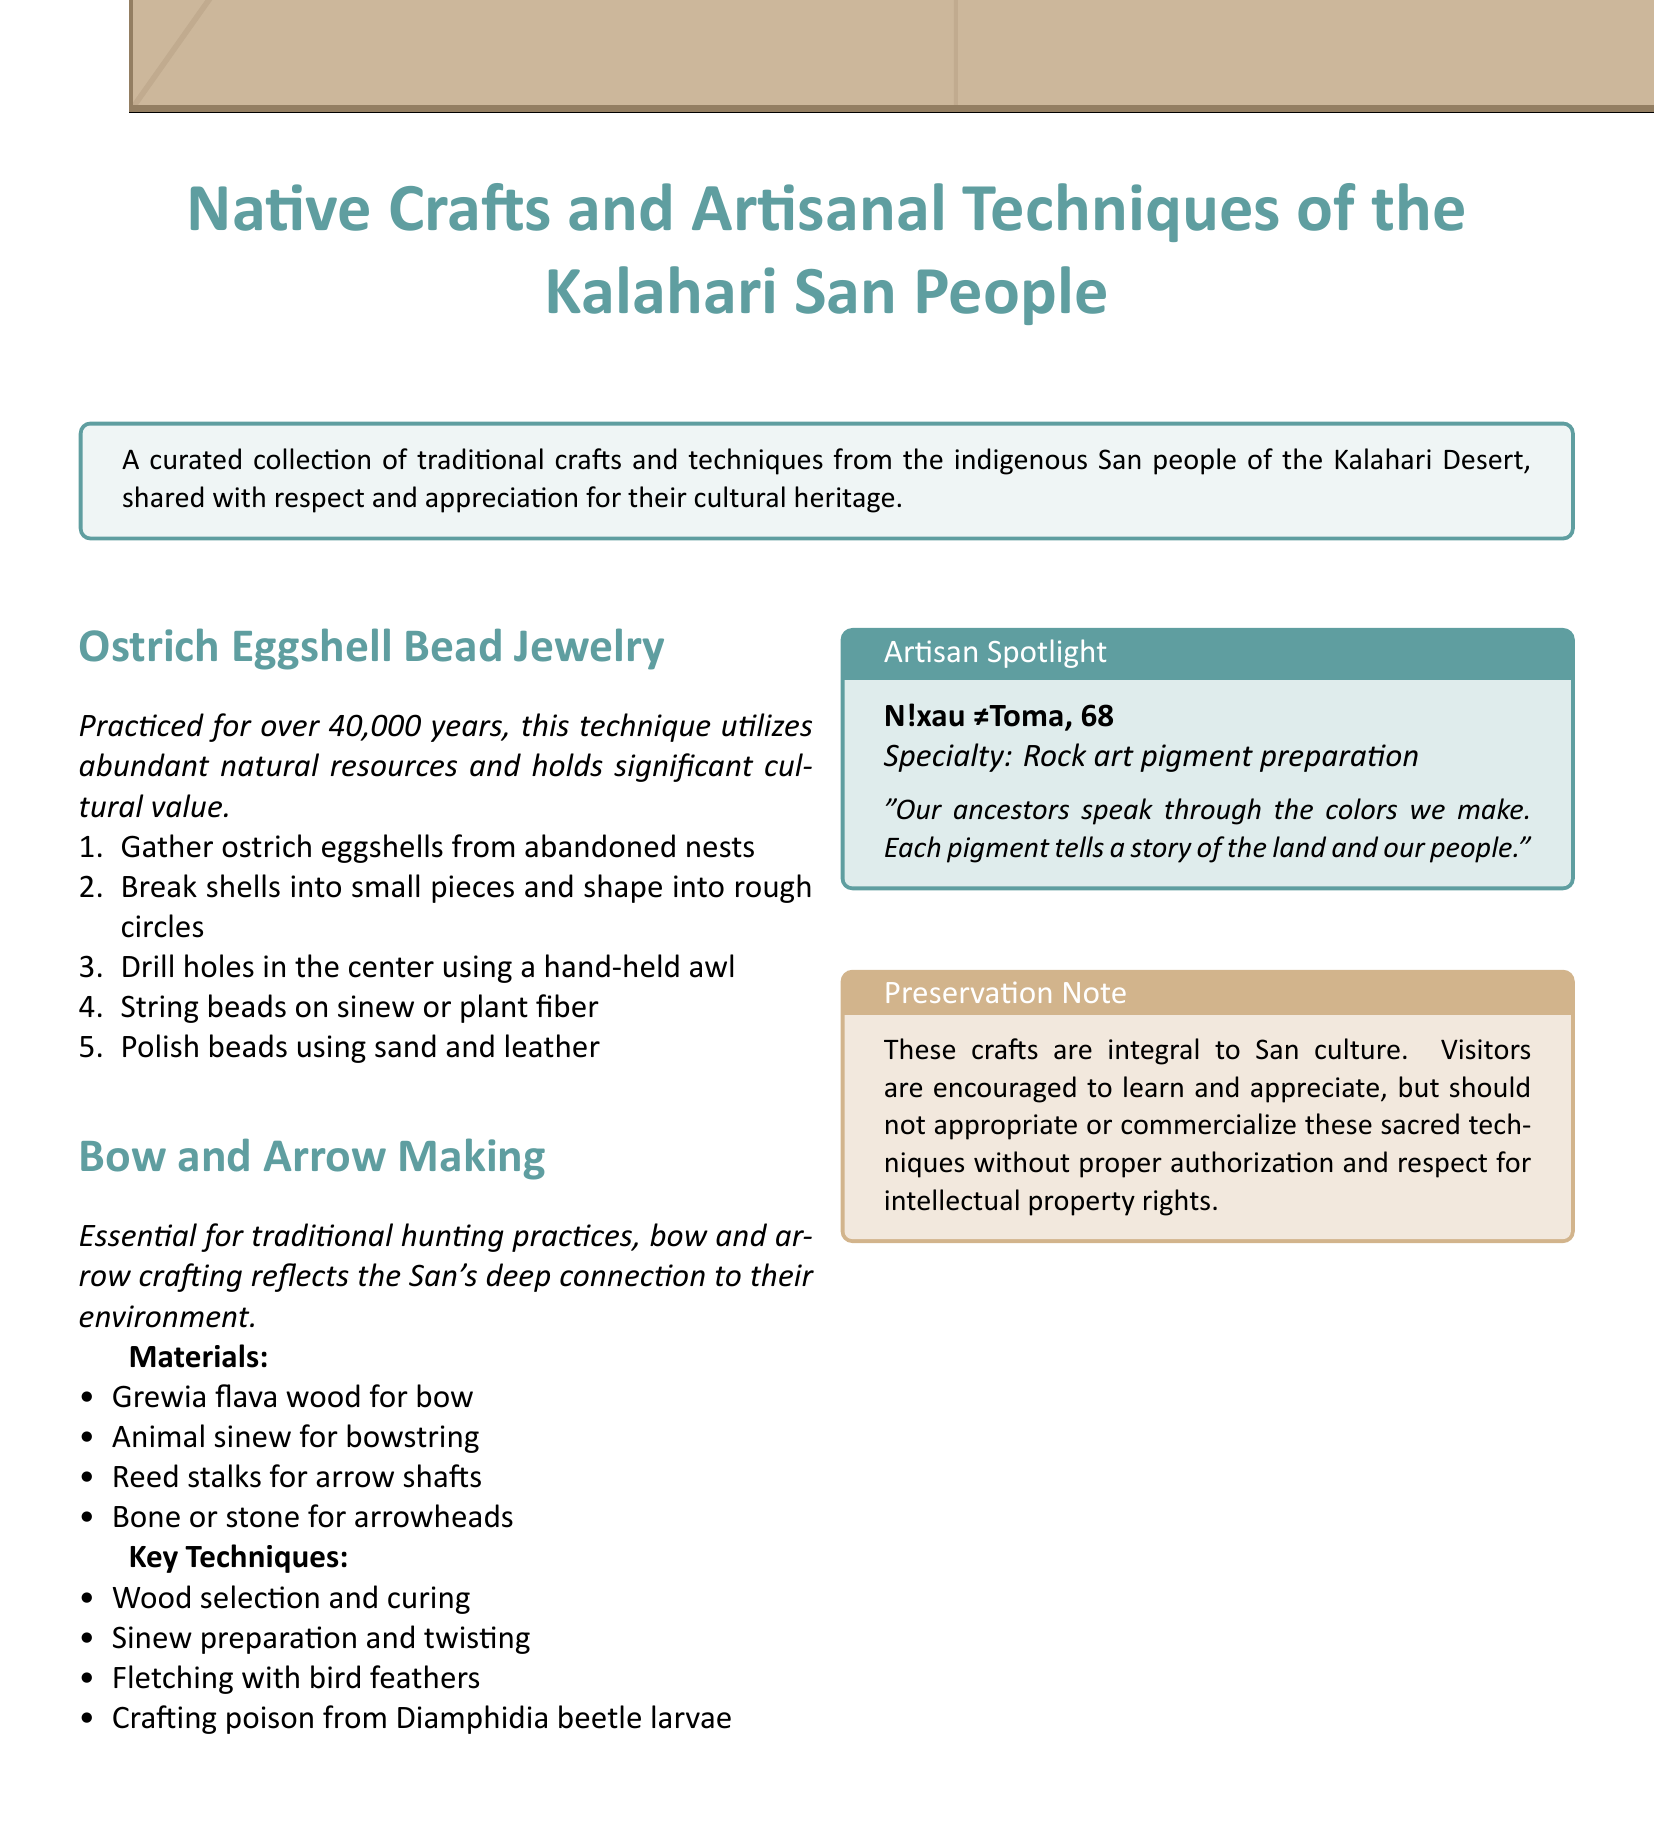What is the main focus of the document? The document focuses on traditional crafts and techniques from the indigenous San people of the Kalahari Desert.
Answer: Native Crafts and Artisanal Techniques of the Kalahari San People How long has ostrich eggshell bead jewelry been practiced? The document states that this technique has been practiced for over 40,000 years.
Answer: 40,000 years What material is used for the bow in bow and arrow making? The document specifies that Grewia flava wood is used for crafting the bow.
Answer: Grewia flava wood Who is spotlighted as an artisan? The document mentions N!xau ≠Toma as the featured artisan.
Answer: N!xau ≠Toma What type of pigment does N!xau ≠Toma prepare? The document identifies the specialty of N!xau ≠Toma as rock art pigment preparation.
Answer: Rock art pigment What is a key technique in making bow and arrows? The document lists wood selection and curing as a key technique.
Answer: Wood selection and curing What should visitors do regarding the crafts? The preservation note instructs visitors to learn and appreciate without appropriating or commercializing the techniques.
Answer: Learn and appreciate What kind of materials are arrow shafts made from? The document states that reed stalks are used for making arrow shafts.
Answer: Reed stalks 